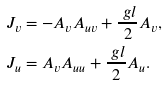Convert formula to latex. <formula><loc_0><loc_0><loc_500><loc_500>J _ { v } & = - A _ { v } A _ { u v } + \frac { \ g l } 2 A _ { v } , \\ J _ { u } & = A _ { v } A _ { u u } + \frac { \ g l } 2 A _ { u } .</formula> 